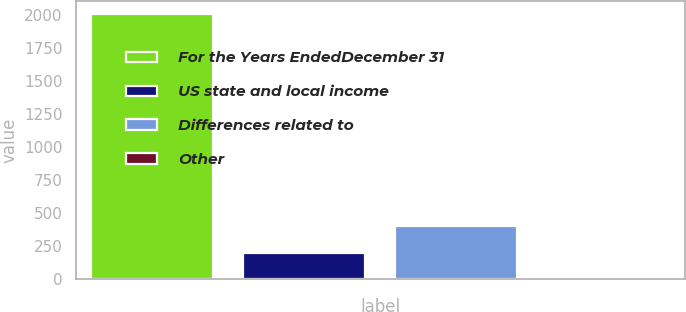Convert chart to OTSL. <chart><loc_0><loc_0><loc_500><loc_500><bar_chart><fcel>For the Years EndedDecember 31<fcel>US state and local income<fcel>Differences related to<fcel>Other<nl><fcel>2010<fcel>201.63<fcel>402.56<fcel>0.7<nl></chart> 